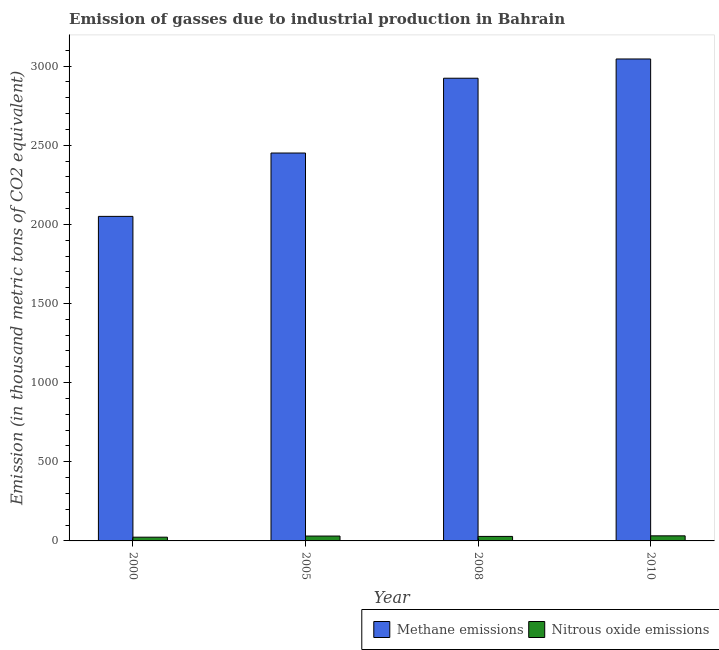How many different coloured bars are there?
Your response must be concise. 2. How many groups of bars are there?
Offer a very short reply. 4. Are the number of bars per tick equal to the number of legend labels?
Offer a terse response. Yes. Are the number of bars on each tick of the X-axis equal?
Your answer should be very brief. Yes. In how many cases, is the number of bars for a given year not equal to the number of legend labels?
Keep it short and to the point. 0. Across all years, what is the maximum amount of nitrous oxide emissions?
Ensure brevity in your answer.  32.1. Across all years, what is the minimum amount of nitrous oxide emissions?
Your answer should be compact. 23.6. In which year was the amount of methane emissions minimum?
Your answer should be compact. 2000. What is the total amount of methane emissions in the graph?
Ensure brevity in your answer.  1.05e+04. What is the difference between the amount of nitrous oxide emissions in 2000 and that in 2008?
Provide a succinct answer. -4.9. What is the difference between the amount of methane emissions in 2005 and the amount of nitrous oxide emissions in 2008?
Keep it short and to the point. -472.6. What is the average amount of methane emissions per year?
Ensure brevity in your answer.  2617.22. In the year 2008, what is the difference between the amount of nitrous oxide emissions and amount of methane emissions?
Keep it short and to the point. 0. In how many years, is the amount of nitrous oxide emissions greater than 1600 thousand metric tons?
Make the answer very short. 0. What is the ratio of the amount of methane emissions in 2000 to that in 2008?
Give a very brief answer. 0.7. Is the amount of nitrous oxide emissions in 2008 less than that in 2010?
Your response must be concise. Yes. What is the difference between the highest and the second highest amount of nitrous oxide emissions?
Your answer should be very brief. 1.4. What is the difference between the highest and the lowest amount of methane emissions?
Give a very brief answer. 994.5. In how many years, is the amount of nitrous oxide emissions greater than the average amount of nitrous oxide emissions taken over all years?
Your answer should be compact. 2. Is the sum of the amount of nitrous oxide emissions in 2000 and 2010 greater than the maximum amount of methane emissions across all years?
Make the answer very short. Yes. What does the 2nd bar from the left in 2008 represents?
Provide a short and direct response. Nitrous oxide emissions. What does the 1st bar from the right in 2008 represents?
Your answer should be compact. Nitrous oxide emissions. How many years are there in the graph?
Provide a short and direct response. 4. What is the difference between two consecutive major ticks on the Y-axis?
Your answer should be compact. 500. Does the graph contain any zero values?
Offer a terse response. No. Does the graph contain grids?
Keep it short and to the point. No. How many legend labels are there?
Ensure brevity in your answer.  2. What is the title of the graph?
Make the answer very short. Emission of gasses due to industrial production in Bahrain. What is the label or title of the Y-axis?
Keep it short and to the point. Emission (in thousand metric tons of CO2 equivalent). What is the Emission (in thousand metric tons of CO2 equivalent) of Methane emissions in 2000?
Keep it short and to the point. 2050.3. What is the Emission (in thousand metric tons of CO2 equivalent) in Nitrous oxide emissions in 2000?
Provide a short and direct response. 23.6. What is the Emission (in thousand metric tons of CO2 equivalent) in Methane emissions in 2005?
Provide a short and direct response. 2450.6. What is the Emission (in thousand metric tons of CO2 equivalent) of Nitrous oxide emissions in 2005?
Your response must be concise. 30.7. What is the Emission (in thousand metric tons of CO2 equivalent) of Methane emissions in 2008?
Ensure brevity in your answer.  2923.2. What is the Emission (in thousand metric tons of CO2 equivalent) in Methane emissions in 2010?
Provide a succinct answer. 3044.8. What is the Emission (in thousand metric tons of CO2 equivalent) in Nitrous oxide emissions in 2010?
Offer a terse response. 32.1. Across all years, what is the maximum Emission (in thousand metric tons of CO2 equivalent) in Methane emissions?
Your answer should be compact. 3044.8. Across all years, what is the maximum Emission (in thousand metric tons of CO2 equivalent) of Nitrous oxide emissions?
Give a very brief answer. 32.1. Across all years, what is the minimum Emission (in thousand metric tons of CO2 equivalent) in Methane emissions?
Your response must be concise. 2050.3. Across all years, what is the minimum Emission (in thousand metric tons of CO2 equivalent) in Nitrous oxide emissions?
Your answer should be compact. 23.6. What is the total Emission (in thousand metric tons of CO2 equivalent) in Methane emissions in the graph?
Ensure brevity in your answer.  1.05e+04. What is the total Emission (in thousand metric tons of CO2 equivalent) of Nitrous oxide emissions in the graph?
Ensure brevity in your answer.  114.9. What is the difference between the Emission (in thousand metric tons of CO2 equivalent) of Methane emissions in 2000 and that in 2005?
Keep it short and to the point. -400.3. What is the difference between the Emission (in thousand metric tons of CO2 equivalent) of Methane emissions in 2000 and that in 2008?
Provide a succinct answer. -872.9. What is the difference between the Emission (in thousand metric tons of CO2 equivalent) in Nitrous oxide emissions in 2000 and that in 2008?
Make the answer very short. -4.9. What is the difference between the Emission (in thousand metric tons of CO2 equivalent) of Methane emissions in 2000 and that in 2010?
Give a very brief answer. -994.5. What is the difference between the Emission (in thousand metric tons of CO2 equivalent) in Methane emissions in 2005 and that in 2008?
Keep it short and to the point. -472.6. What is the difference between the Emission (in thousand metric tons of CO2 equivalent) of Nitrous oxide emissions in 2005 and that in 2008?
Your answer should be compact. 2.2. What is the difference between the Emission (in thousand metric tons of CO2 equivalent) of Methane emissions in 2005 and that in 2010?
Offer a terse response. -594.2. What is the difference between the Emission (in thousand metric tons of CO2 equivalent) in Nitrous oxide emissions in 2005 and that in 2010?
Provide a short and direct response. -1.4. What is the difference between the Emission (in thousand metric tons of CO2 equivalent) in Methane emissions in 2008 and that in 2010?
Ensure brevity in your answer.  -121.6. What is the difference between the Emission (in thousand metric tons of CO2 equivalent) of Nitrous oxide emissions in 2008 and that in 2010?
Your answer should be compact. -3.6. What is the difference between the Emission (in thousand metric tons of CO2 equivalent) in Methane emissions in 2000 and the Emission (in thousand metric tons of CO2 equivalent) in Nitrous oxide emissions in 2005?
Keep it short and to the point. 2019.6. What is the difference between the Emission (in thousand metric tons of CO2 equivalent) of Methane emissions in 2000 and the Emission (in thousand metric tons of CO2 equivalent) of Nitrous oxide emissions in 2008?
Make the answer very short. 2021.8. What is the difference between the Emission (in thousand metric tons of CO2 equivalent) of Methane emissions in 2000 and the Emission (in thousand metric tons of CO2 equivalent) of Nitrous oxide emissions in 2010?
Give a very brief answer. 2018.2. What is the difference between the Emission (in thousand metric tons of CO2 equivalent) of Methane emissions in 2005 and the Emission (in thousand metric tons of CO2 equivalent) of Nitrous oxide emissions in 2008?
Offer a very short reply. 2422.1. What is the difference between the Emission (in thousand metric tons of CO2 equivalent) in Methane emissions in 2005 and the Emission (in thousand metric tons of CO2 equivalent) in Nitrous oxide emissions in 2010?
Your answer should be very brief. 2418.5. What is the difference between the Emission (in thousand metric tons of CO2 equivalent) of Methane emissions in 2008 and the Emission (in thousand metric tons of CO2 equivalent) of Nitrous oxide emissions in 2010?
Offer a terse response. 2891.1. What is the average Emission (in thousand metric tons of CO2 equivalent) in Methane emissions per year?
Your response must be concise. 2617.22. What is the average Emission (in thousand metric tons of CO2 equivalent) in Nitrous oxide emissions per year?
Give a very brief answer. 28.73. In the year 2000, what is the difference between the Emission (in thousand metric tons of CO2 equivalent) of Methane emissions and Emission (in thousand metric tons of CO2 equivalent) of Nitrous oxide emissions?
Keep it short and to the point. 2026.7. In the year 2005, what is the difference between the Emission (in thousand metric tons of CO2 equivalent) of Methane emissions and Emission (in thousand metric tons of CO2 equivalent) of Nitrous oxide emissions?
Keep it short and to the point. 2419.9. In the year 2008, what is the difference between the Emission (in thousand metric tons of CO2 equivalent) in Methane emissions and Emission (in thousand metric tons of CO2 equivalent) in Nitrous oxide emissions?
Your response must be concise. 2894.7. In the year 2010, what is the difference between the Emission (in thousand metric tons of CO2 equivalent) in Methane emissions and Emission (in thousand metric tons of CO2 equivalent) in Nitrous oxide emissions?
Offer a very short reply. 3012.7. What is the ratio of the Emission (in thousand metric tons of CO2 equivalent) in Methane emissions in 2000 to that in 2005?
Your answer should be compact. 0.84. What is the ratio of the Emission (in thousand metric tons of CO2 equivalent) of Nitrous oxide emissions in 2000 to that in 2005?
Offer a very short reply. 0.77. What is the ratio of the Emission (in thousand metric tons of CO2 equivalent) in Methane emissions in 2000 to that in 2008?
Ensure brevity in your answer.  0.7. What is the ratio of the Emission (in thousand metric tons of CO2 equivalent) in Nitrous oxide emissions in 2000 to that in 2008?
Keep it short and to the point. 0.83. What is the ratio of the Emission (in thousand metric tons of CO2 equivalent) in Methane emissions in 2000 to that in 2010?
Your response must be concise. 0.67. What is the ratio of the Emission (in thousand metric tons of CO2 equivalent) in Nitrous oxide emissions in 2000 to that in 2010?
Offer a terse response. 0.74. What is the ratio of the Emission (in thousand metric tons of CO2 equivalent) of Methane emissions in 2005 to that in 2008?
Provide a succinct answer. 0.84. What is the ratio of the Emission (in thousand metric tons of CO2 equivalent) of Nitrous oxide emissions in 2005 to that in 2008?
Offer a very short reply. 1.08. What is the ratio of the Emission (in thousand metric tons of CO2 equivalent) in Methane emissions in 2005 to that in 2010?
Offer a very short reply. 0.8. What is the ratio of the Emission (in thousand metric tons of CO2 equivalent) of Nitrous oxide emissions in 2005 to that in 2010?
Your answer should be compact. 0.96. What is the ratio of the Emission (in thousand metric tons of CO2 equivalent) in Methane emissions in 2008 to that in 2010?
Ensure brevity in your answer.  0.96. What is the ratio of the Emission (in thousand metric tons of CO2 equivalent) of Nitrous oxide emissions in 2008 to that in 2010?
Give a very brief answer. 0.89. What is the difference between the highest and the second highest Emission (in thousand metric tons of CO2 equivalent) of Methane emissions?
Your answer should be very brief. 121.6. What is the difference between the highest and the lowest Emission (in thousand metric tons of CO2 equivalent) of Methane emissions?
Give a very brief answer. 994.5. 